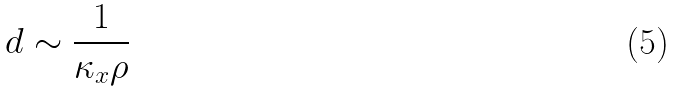Convert formula to latex. <formula><loc_0><loc_0><loc_500><loc_500>d \sim \frac { 1 } { \kappa _ { x } \rho }</formula> 